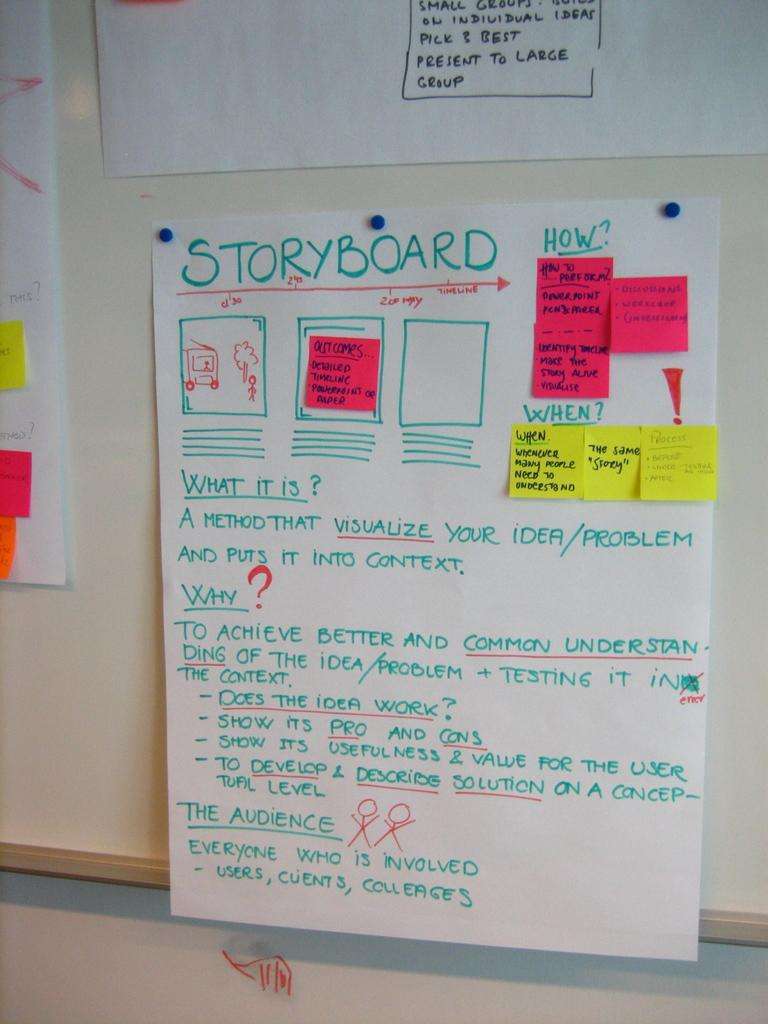<image>
Create a compact narrative representing the image presented. a large storyboard that has the word storyboard on it 